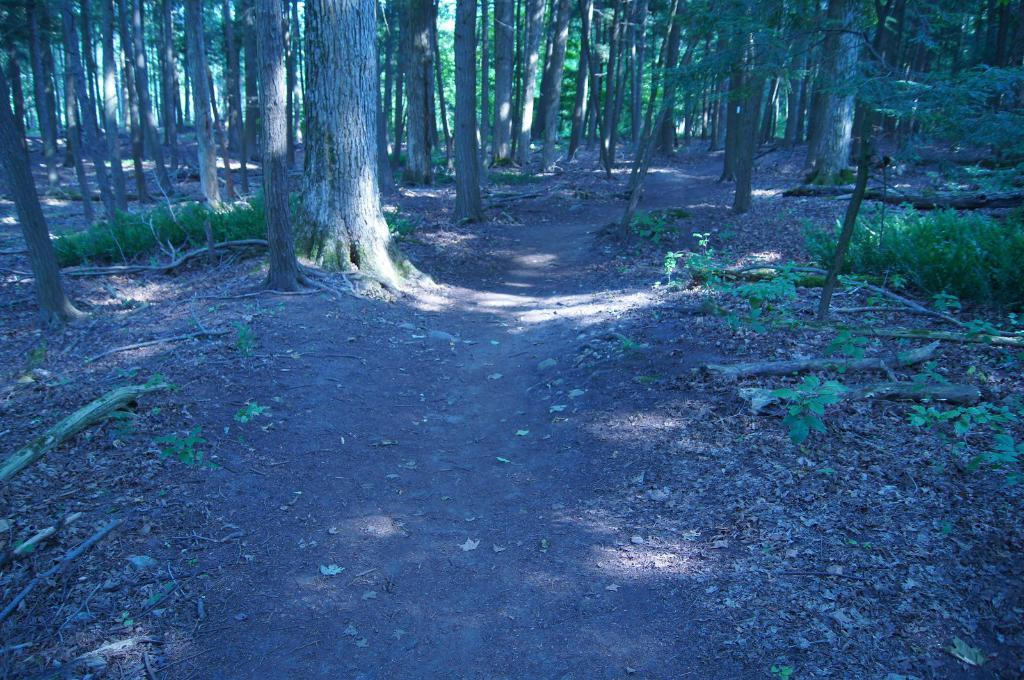What is the main feature of the landscape in the image? There are many trees in the image. How are the trees distributed across the land? The trees are spread across the land. Is there any visible path or road in the image? Yes, there is a path in the middle of the land. What type of statement can be seen written on the trees in the image? There are no statements written on the trees in the image; it only features trees and a path. How many roses can be seen growing on the trees in the image? There are no roses present on the trees in the image. 